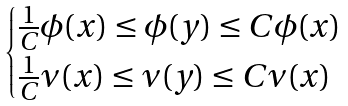<formula> <loc_0><loc_0><loc_500><loc_500>\begin{cases} \frac { 1 } { C } \phi ( x ) \leq \phi ( y ) \leq C \phi ( x ) \\ \frac { 1 } { C } \nu ( x ) \leq \nu ( y ) \leq C \nu ( x ) \end{cases}</formula> 